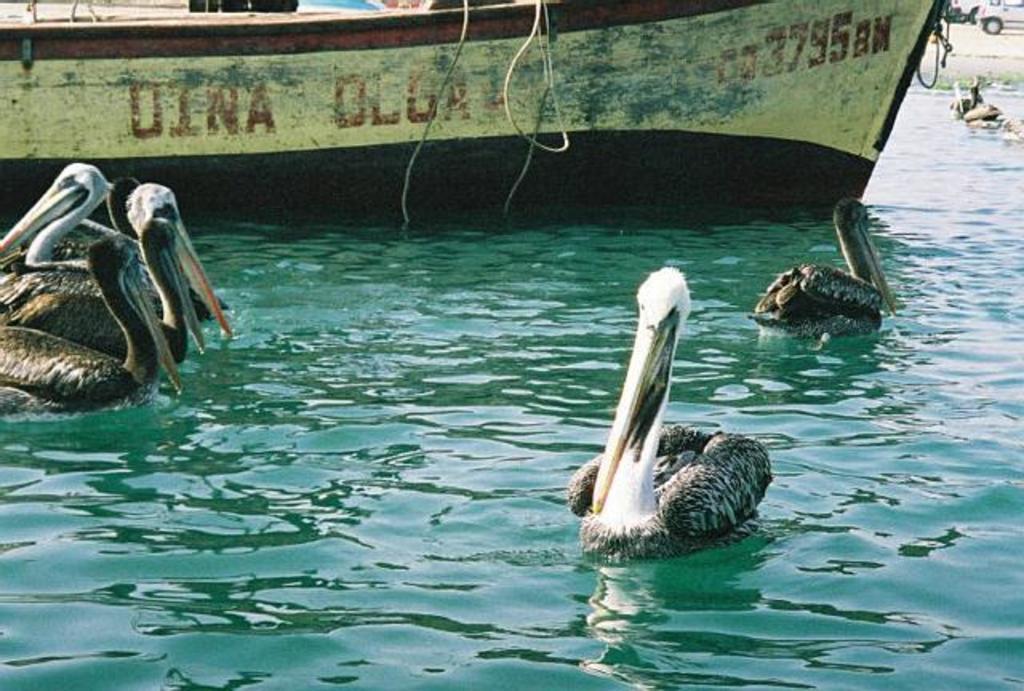In one or two sentences, can you explain what this image depicts? In this image I can see few birds in the water and they are in black and white color. I can see a boat on the water. Back I can see few vehicles. 